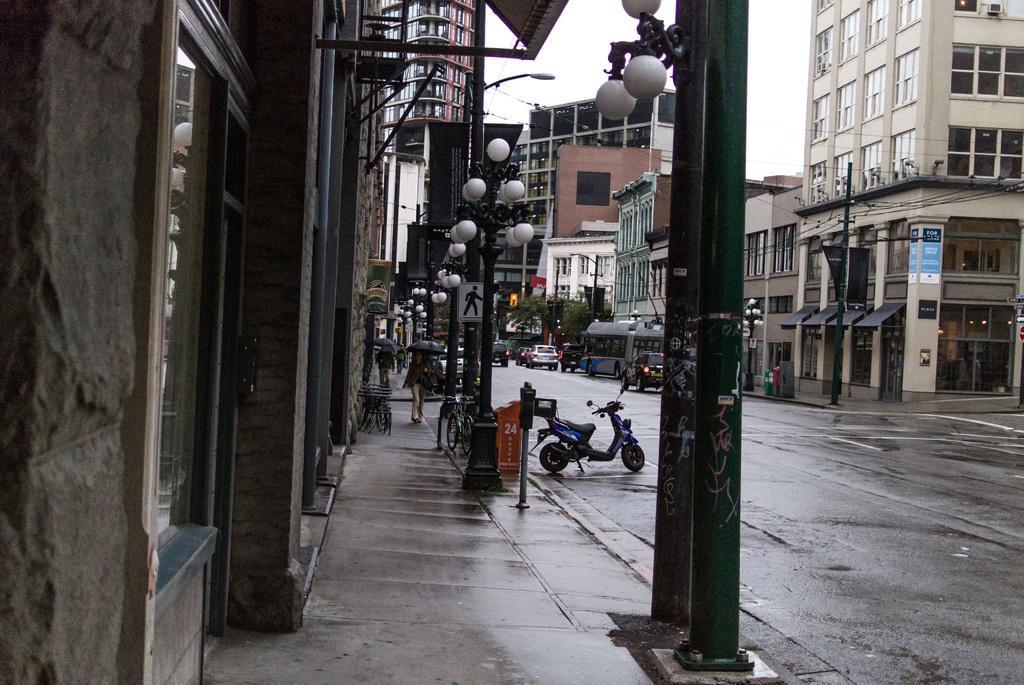Could you give a brief overview of what you see in this image? This picture is clicked outside. In the center we can see the lamp posts, group of persons, umbrellas and vehicles and we can see the buildings. In the background we can see the sky, trees and some other objects and we can see the metal rods. 